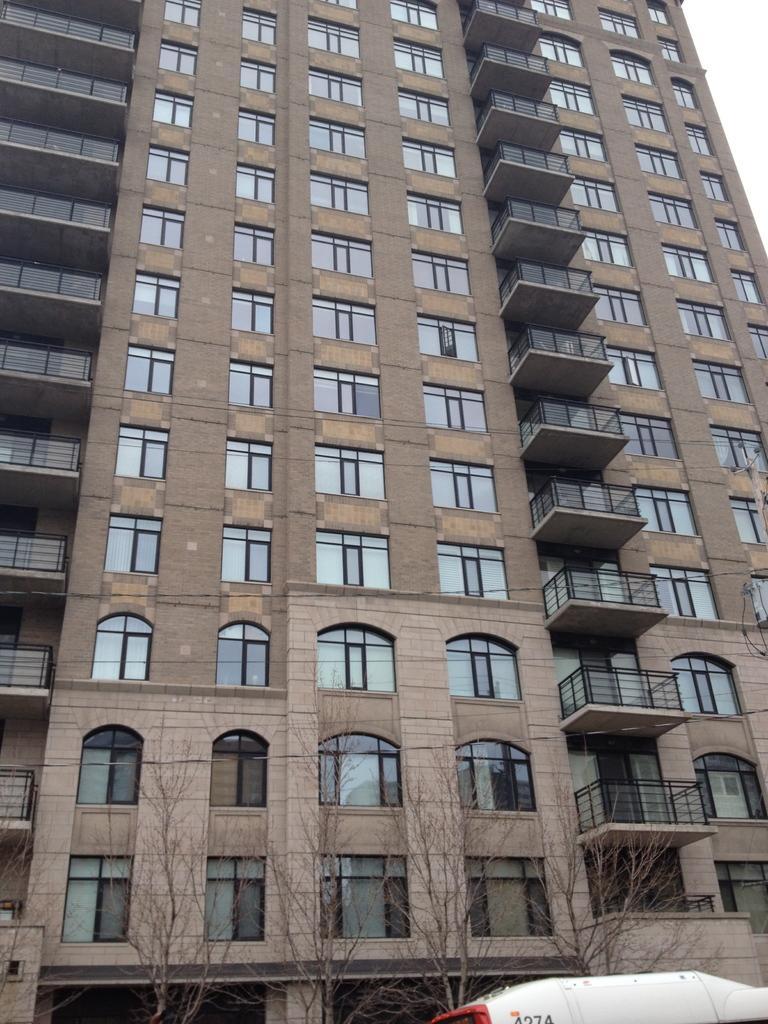Could you give a brief overview of what you see in this image? In this image we can see a building, there are some trees, windows, grille and a vehicle. 